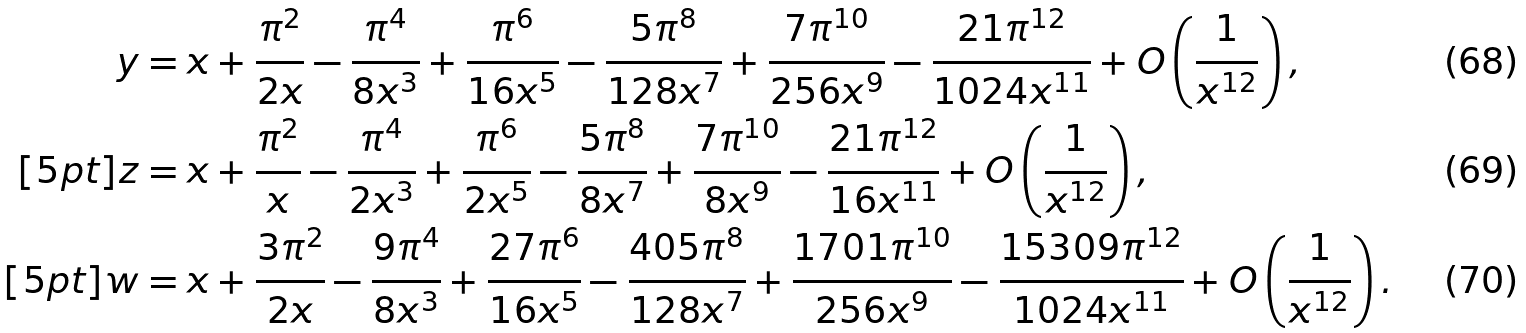Convert formula to latex. <formula><loc_0><loc_0><loc_500><loc_500>y & = x + \frac { \pi ^ { 2 } } { 2 x } - \frac { \pi ^ { 4 } } { 8 x ^ { 3 } } + \frac { \pi ^ { 6 } } { 1 6 x ^ { 5 } } - \frac { 5 \pi ^ { 8 } } { 1 2 8 x ^ { 7 } } + \frac { 7 \pi ^ { 1 0 } } { 2 5 6 x ^ { 9 } } - \frac { 2 1 \pi ^ { 1 2 } } { 1 0 2 4 x ^ { 1 1 } } + O \left ( \frac { 1 } { x ^ { 1 2 } } \right ) , \\ [ 5 p t ] z & = x + \frac { \pi ^ { 2 } } { x } - \frac { \pi ^ { 4 } } { 2 x ^ { 3 } } + \frac { \pi ^ { 6 } } { 2 x ^ { 5 } } - \frac { 5 \pi ^ { 8 } } { 8 x ^ { 7 } } + \frac { 7 \pi ^ { 1 0 } } { 8 x ^ { 9 } } - \frac { 2 1 \pi ^ { 1 2 } } { 1 6 x ^ { 1 1 } } + O \left ( \frac { 1 } { x ^ { 1 2 } } \right ) , \\ [ 5 p t ] w & = x + \frac { 3 \pi ^ { 2 } } { 2 x } - \frac { 9 \pi ^ { 4 } } { 8 x ^ { 3 } } + \frac { 2 7 \pi ^ { 6 } } { 1 6 x ^ { 5 } } - \frac { 4 0 5 \pi ^ { 8 } } { 1 2 8 x ^ { 7 } } + \frac { 1 7 0 1 \pi ^ { 1 0 } } { 2 5 6 x ^ { 9 } } - \frac { 1 5 3 0 9 \pi ^ { 1 2 } } { 1 0 2 4 x ^ { 1 1 } } + O \left ( \frac { 1 } { x ^ { 1 2 } } \right ) .</formula> 